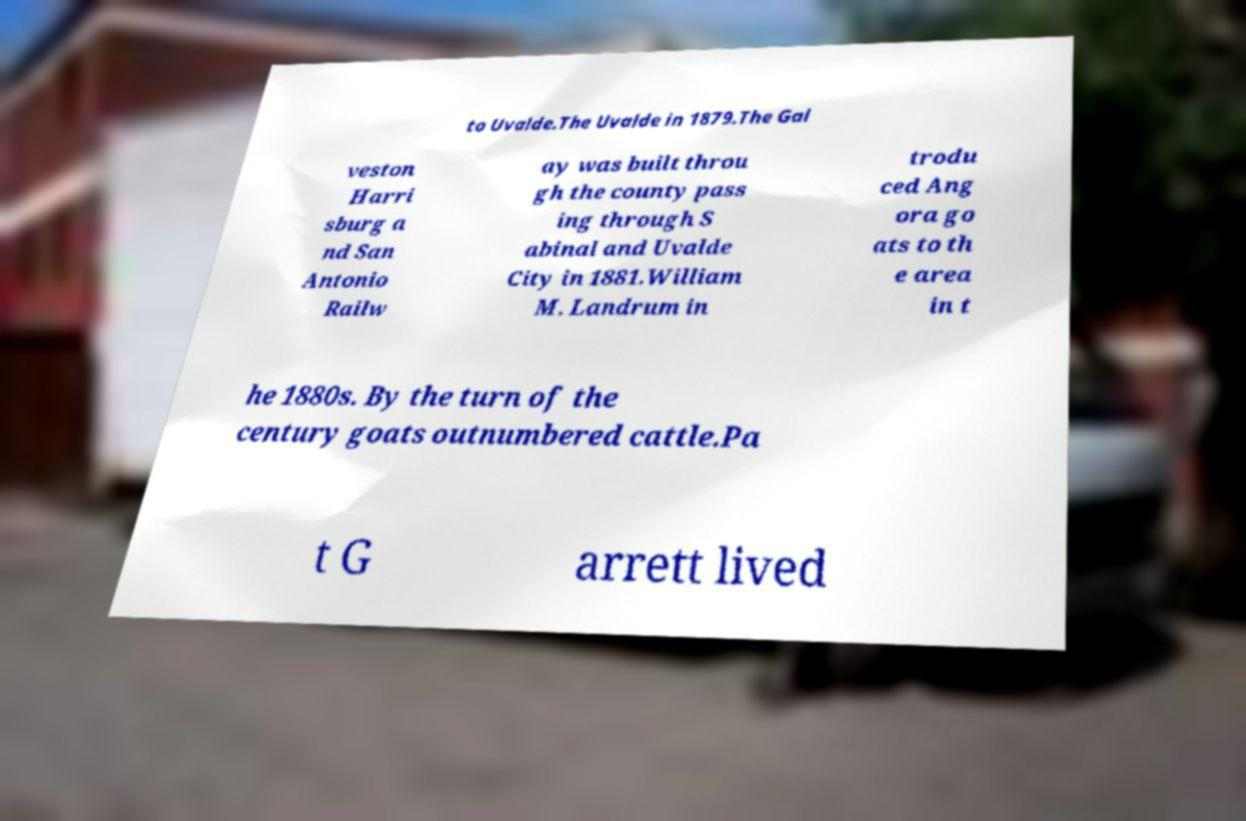What messages or text are displayed in this image? I need them in a readable, typed format. to Uvalde.The Uvalde in 1879.The Gal veston Harri sburg a nd San Antonio Railw ay was built throu gh the county pass ing through S abinal and Uvalde City in 1881.William M. Landrum in trodu ced Ang ora go ats to th e area in t he 1880s. By the turn of the century goats outnumbered cattle.Pa t G arrett lived 